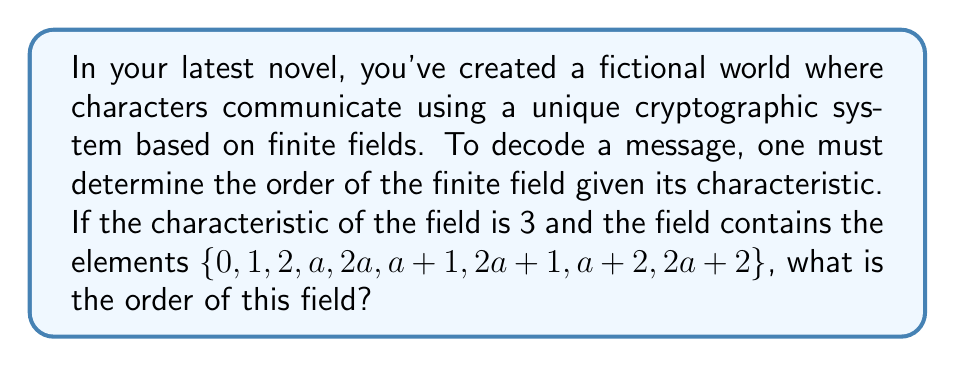Solve this math problem. Let's approach this step-by-step:

1) In a finite field of characteristic $p$, the number of elements is always $p^n$, where $n$ is a positive integer.

2) Given that the characteristic is 3, we know the order will be of the form $3^n$.

3) We're told that the field contains 9 elements. So we need to find $n$ such that:

   $$3^n = 9$$

4) We can solve this by taking the logarithm base 3 of both sides:

   $$\log_3(3^n) = \log_3(9)$$
   $$n = 2$$

5) We can verify: $3^2 = 9$, which matches the number of elements given.

6) The structure of the field also confirms this:
   - It contains the elements $\{0, 1, 2\}$ from $\mathbb{Z}_3$
   - It contains an additional element $a$ and its multiples
   - It contains all possible sums of these elements

This structure is consistent with a field of order $3^2 = 9$.
Answer: $9$ 